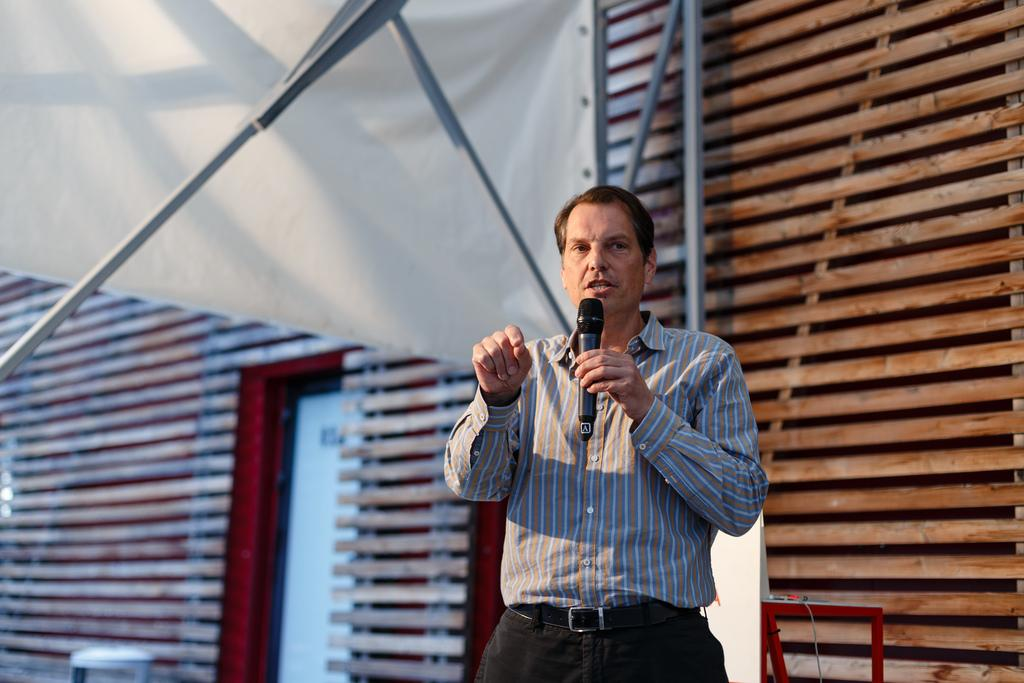What is the main subject of the image? There is a man in the image. What is the man wearing? The man is wearing a check shirt. What is the man holding in the image? The man is holding a microphone. What is the man doing in the image? The man is explaining something. What can be seen in the background of the image? There is a wooden wall and a banner in the background of the image. How many sisters does the man have, and what are their names? There is no information about the man's sisters in the image, so we cannot determine their names or number. 